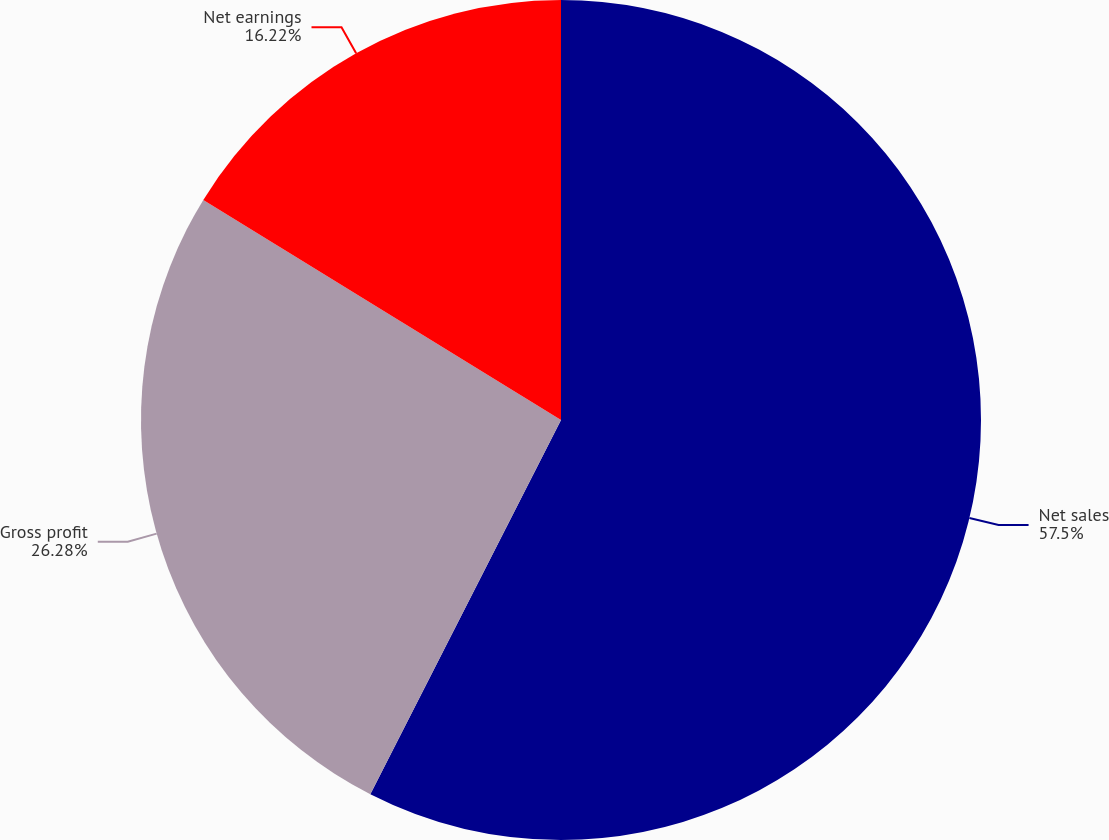Convert chart. <chart><loc_0><loc_0><loc_500><loc_500><pie_chart><fcel>Net sales<fcel>Gross profit<fcel>Net earnings<nl><fcel>57.5%<fcel>26.28%<fcel>16.22%<nl></chart> 